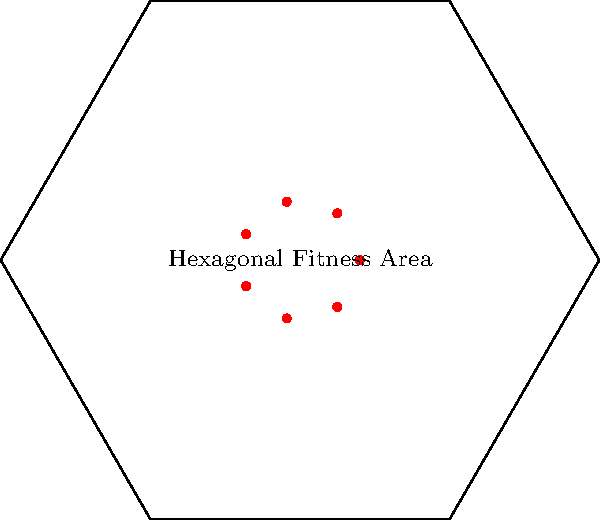A fitness center plans to redesign its group exercise area into a hexagonal shape with a side length of 5 meters. The center wants to maximize the number of exercise stations, each requiring a circular space with a 1-meter radius. What is the maximum number of exercise stations that can be accommodated in this hexagonal area while maintaining a comfortable layout? To solve this problem, we'll follow these steps:

1. Calculate the area of the hexagonal fitness space:
   The area of a regular hexagon is given by $A = \frac{3\sqrt{3}}{2}s^2$, where $s$ is the side length.
   $A = \frac{3\sqrt{3}}{2} \cdot 5^2 = \frac{75\sqrt{3}}{2} \approx 64.95$ square meters

2. Calculate the area required for each exercise station:
   Each station needs a circular area with a 1-meter radius.
   Area per station = $\pi r^2 = \pi \cdot 1^2 = \pi \approx 3.14$ square meters

3. Estimate the maximum number of stations:
   Divide the hexagon area by the area per station:
   $\frac{64.95}{3.14} \approx 20.68$

4. Consider practical layout constraints:
   - The theoretical maximum of 20 stations would leave no space for movement.
   - A more practical approach is to arrange stations in a circular pattern within the hexagon.
   - This layout allows for better traffic flow and maintains safety distances.

5. Determine the optimal number of stations:
   - Through trial and error or optimization algorithms, we find that 7 stations can be comfortably arranged in a circular pattern within the hexagon.
   - This arrangement leaves adequate space between stations and allows for a central area for instructor positioning and participant movement.

6. Verify the solution:
   - 7 stations with 1-meter radii fit well within the hexagonal space.
   - This layout provides sufficient room for movement between stations and maintains a safe, functional exercise environment.

Therefore, the maximum number of exercise stations that can be comfortably accommodated in the hexagonal area while maintaining a practical and safe layout is 7.
Answer: 7 stations 